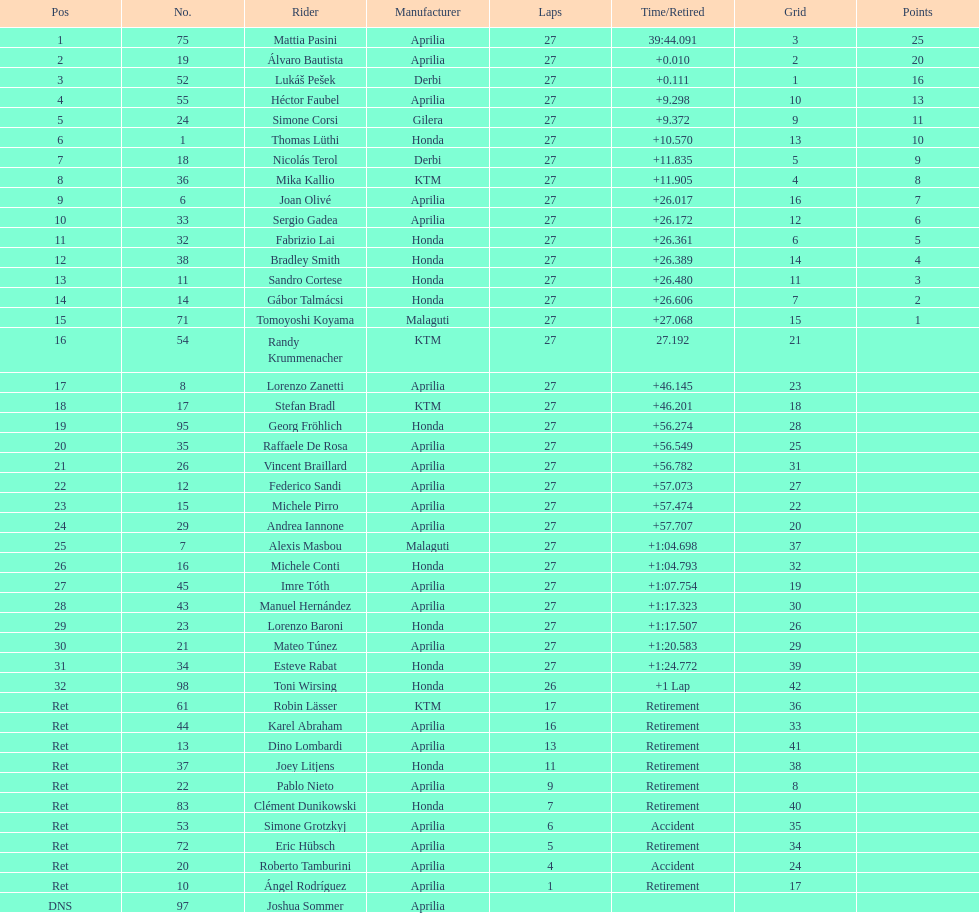How many competitors did not utilize an aprilia or a honda? 9. 